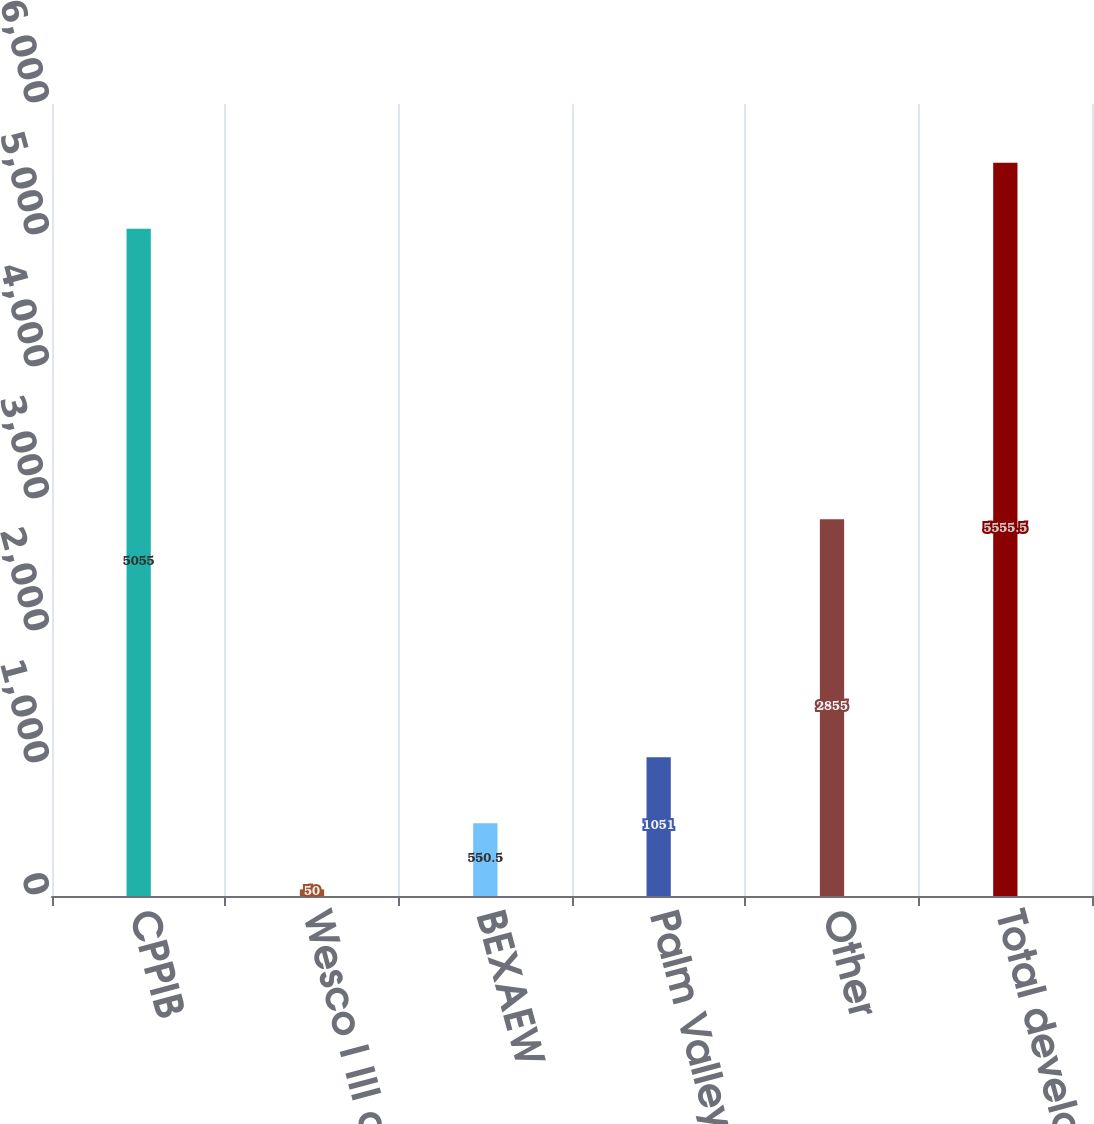<chart> <loc_0><loc_0><loc_500><loc_500><bar_chart><fcel>CPPIB<fcel>Wesco I III and IV<fcel>BEXAEW<fcel>Palm Valley<fcel>Other<fcel>Total development<nl><fcel>5055<fcel>50<fcel>550.5<fcel>1051<fcel>2855<fcel>5555.5<nl></chart> 